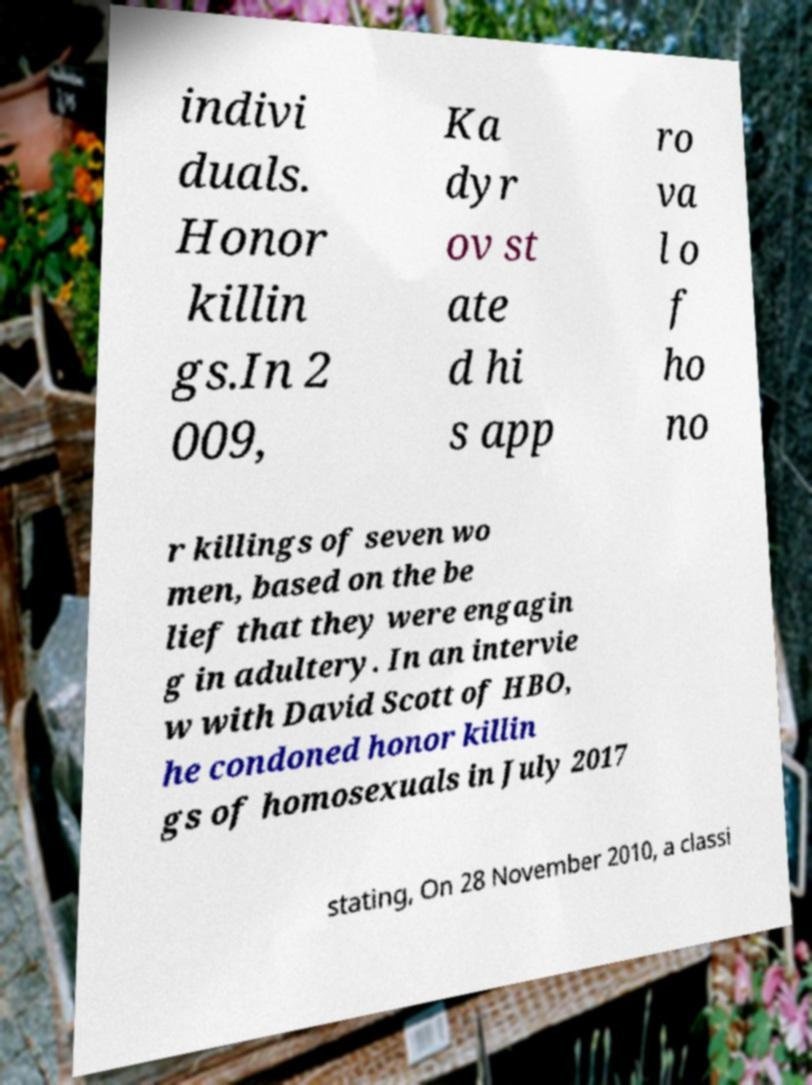I need the written content from this picture converted into text. Can you do that? indivi duals. Honor killin gs.In 2 009, Ka dyr ov st ate d hi s app ro va l o f ho no r killings of seven wo men, based on the be lief that they were engagin g in adultery. In an intervie w with David Scott of HBO, he condoned honor killin gs of homosexuals in July 2017 stating, On 28 November 2010, a classi 